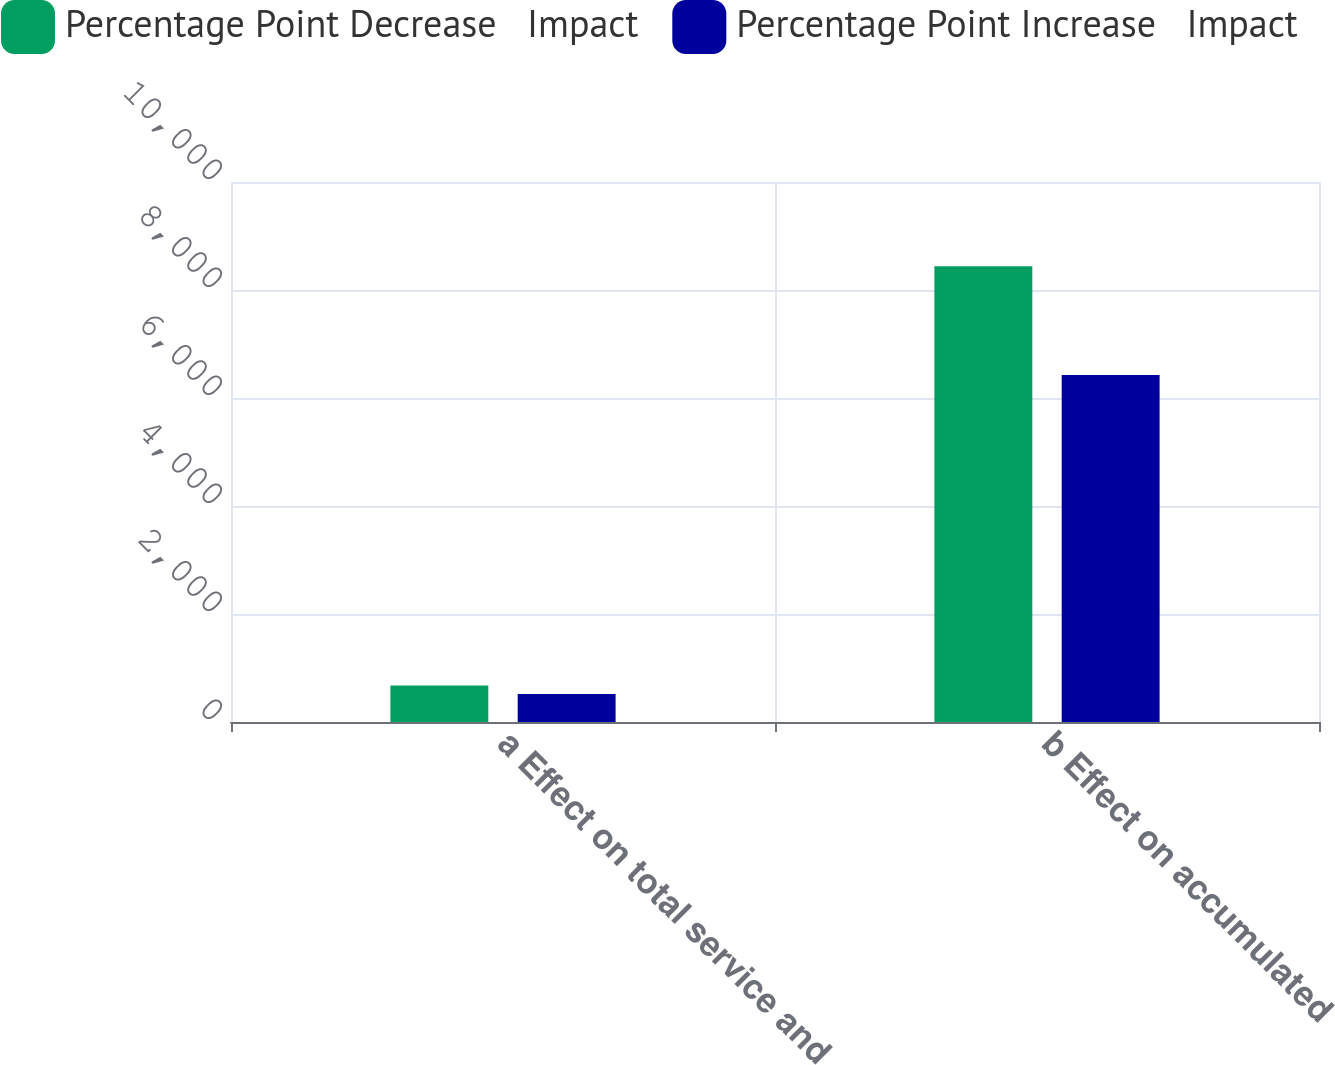<chart> <loc_0><loc_0><loc_500><loc_500><stacked_bar_chart><ecel><fcel>a Effect on total service and<fcel>b Effect on accumulated<nl><fcel>Percentage Point Decrease   Impact<fcel>674<fcel>8442<nl><fcel>Percentage Point Increase   Impact<fcel>518<fcel>6426<nl></chart> 